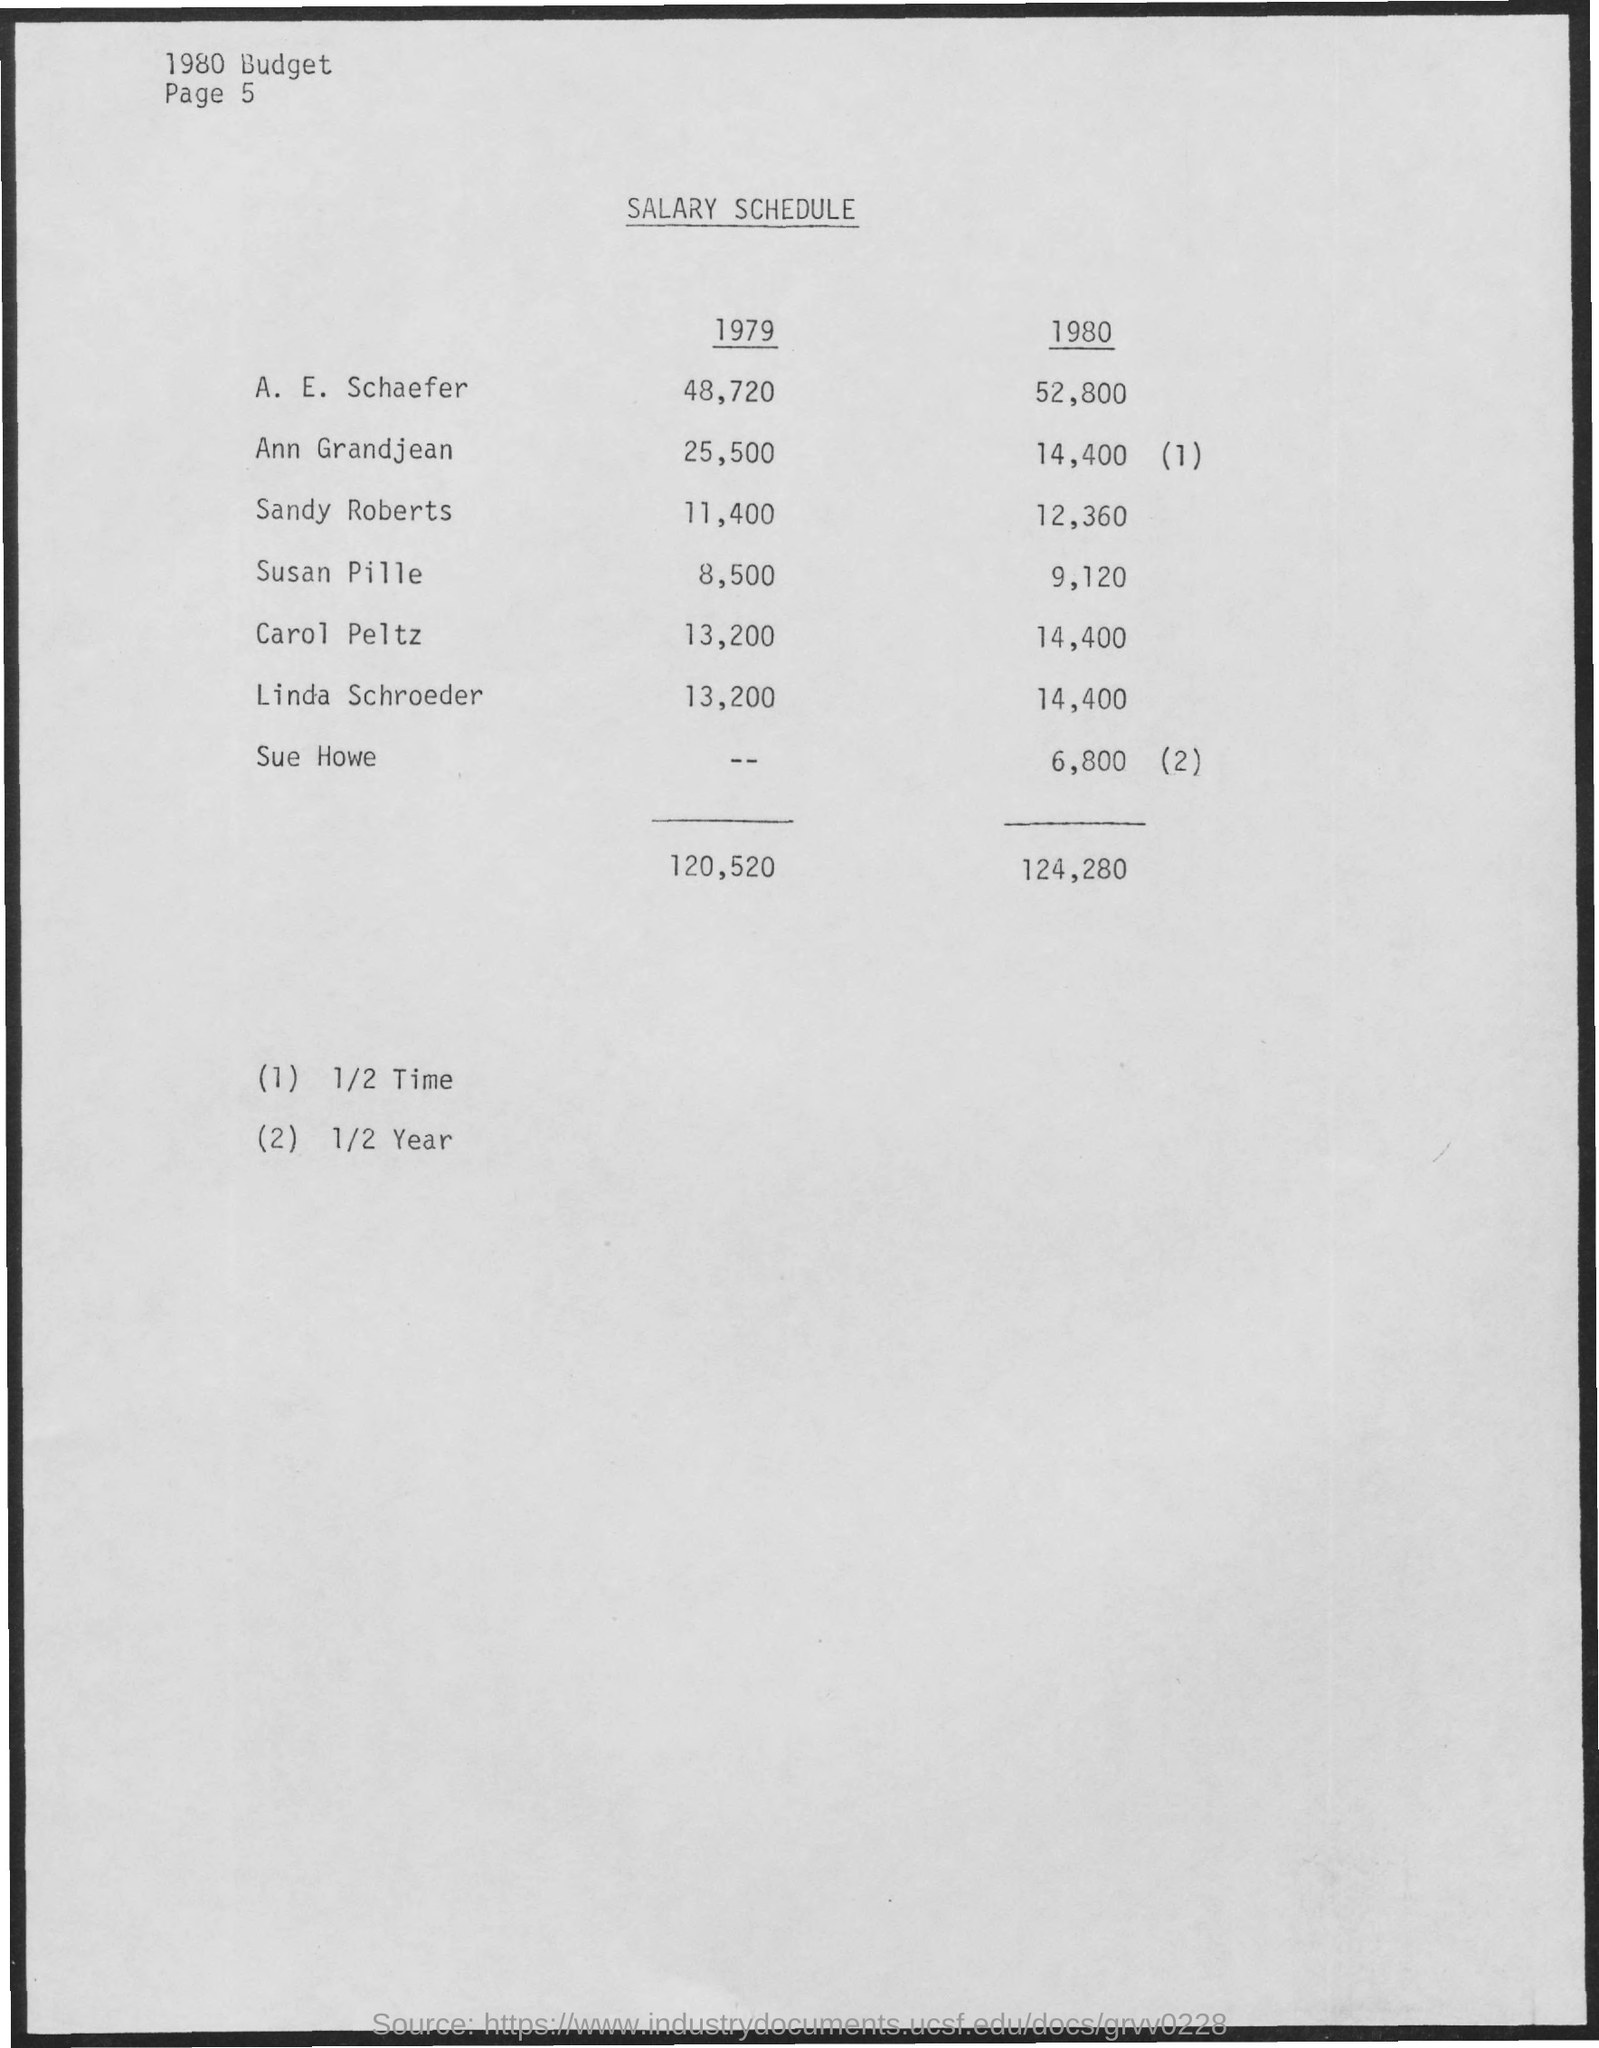What is the Salary Schedule for A. E. Schaefer in 1979?
Provide a succinct answer. 48,720. What is the Salary Schedule for A. E. Schaefer in 1980?
Offer a terse response. 52,800. What is the Salary Schedule for Ann Grandjean in 1979?
Your answer should be very brief. 25,500. What is the Salary  for Ann Grandjean in 1980?
Provide a short and direct response. 14,400 (1). What is the Salary Schedule for Sandy Roberts in 1979?
Provide a short and direct response. 11,400. What is the Salary Schedule for Sandy Roberts in 1980?
Provide a short and direct response. 12,360. What is the Salary Schedule for Susan Pille in 1979?
Your response must be concise. 8,500. What is the Salary Schedule for Susan Pille in 1980?
Provide a succinct answer. 9,120. What is the Salary Schedule for Carol Peltz in 1979?
Offer a very short reply. 13,200. What is the Salary Schedule for Carol Peltz in 1980?
Your answer should be compact. 14,400. 